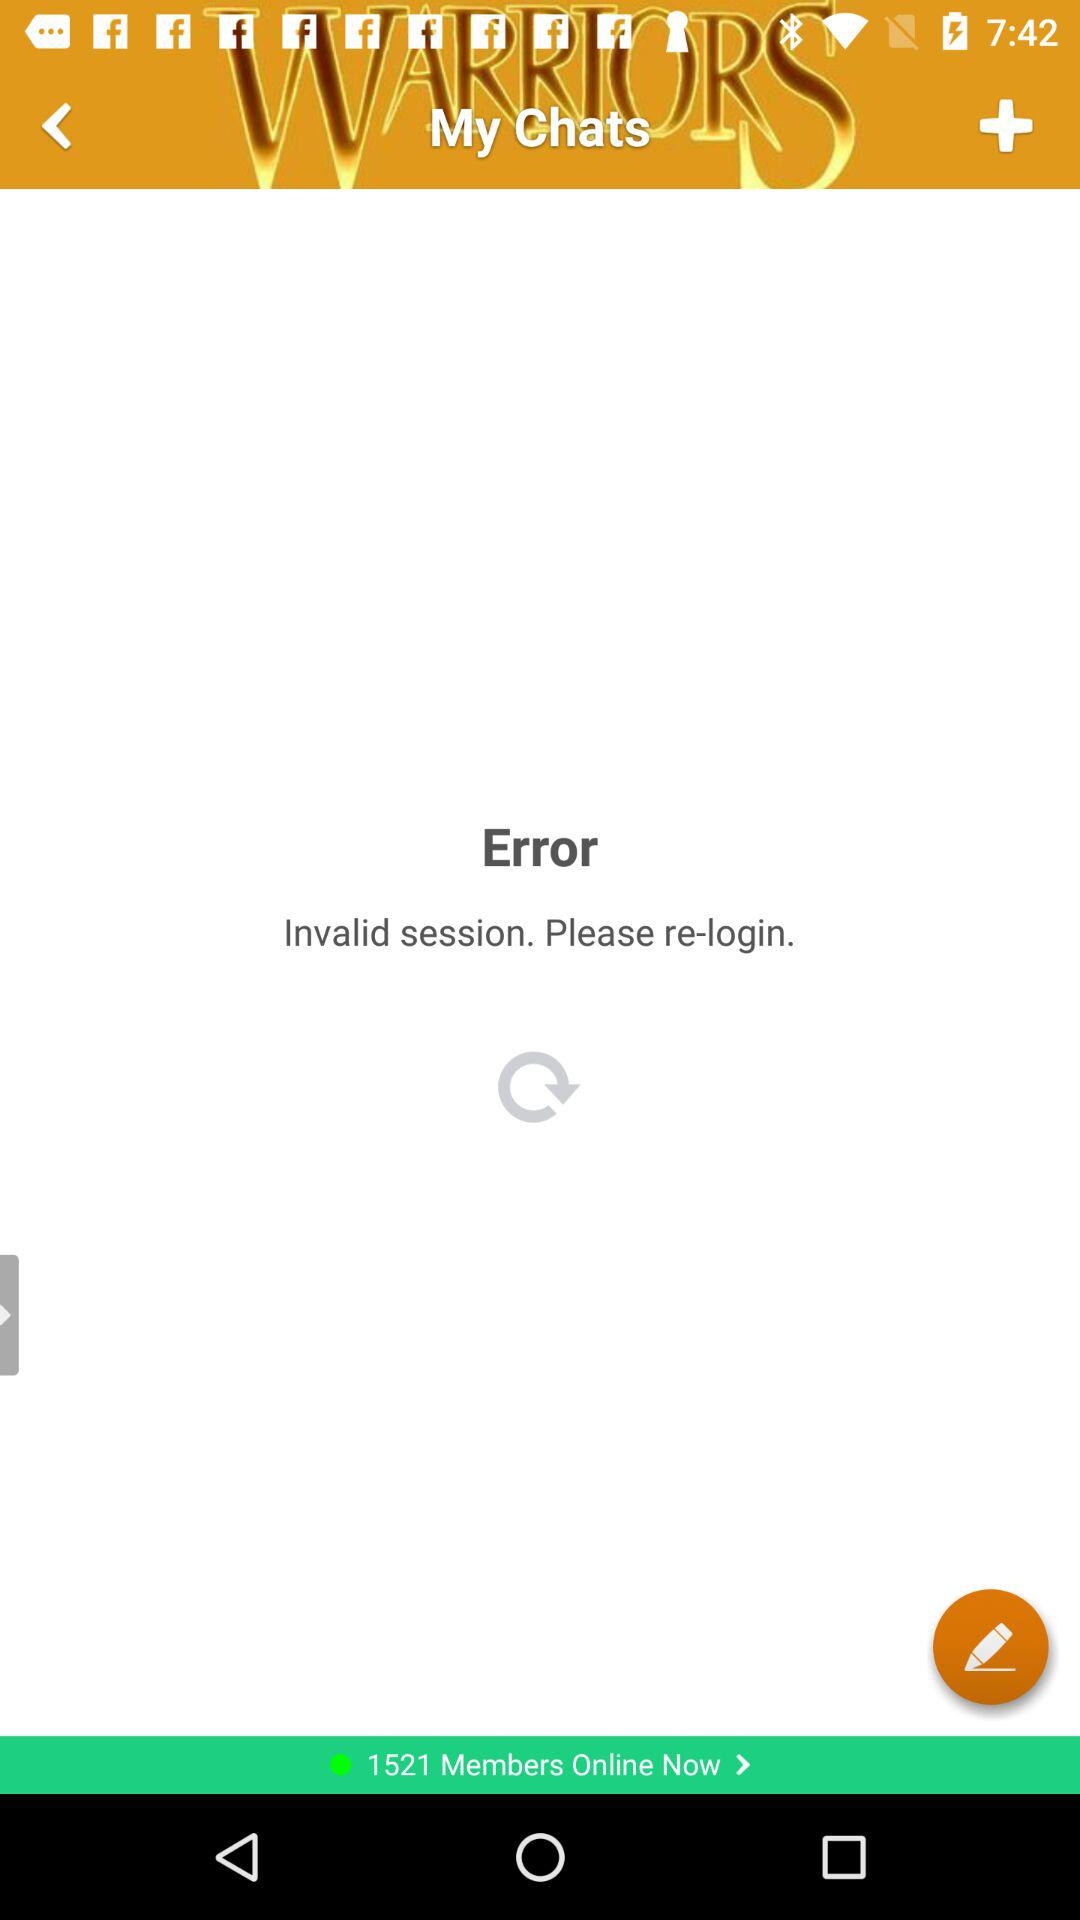What error message is displayed? The displayed error message is "Invalid session. Please re-login". 